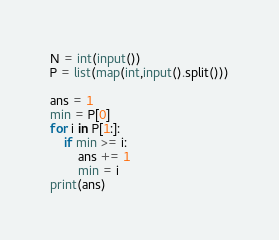Convert code to text. <code><loc_0><loc_0><loc_500><loc_500><_Python_>N = int(input())
P = list(map(int,input().split()))

ans = 1
min = P[0]
for i in P[1:]:
    if min >= i:
        ans += 1
        min = i
print(ans)
</code> 